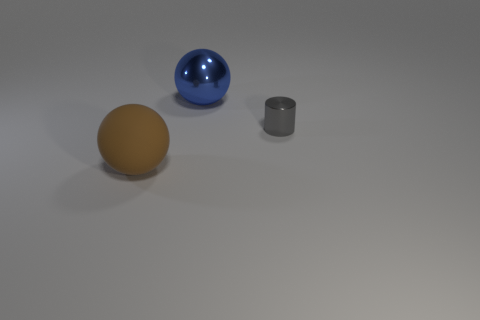Subtract all brown balls. How many balls are left? 1 Subtract 1 cylinders. How many cylinders are left? 0 Add 2 small red matte balls. How many objects exist? 5 Subtract all cylinders. How many objects are left? 2 Add 3 matte objects. How many matte objects exist? 4 Subtract 0 cyan balls. How many objects are left? 3 Subtract all green cylinders. Subtract all green cubes. How many cylinders are left? 1 Subtract all purple cylinders. How many brown balls are left? 1 Subtract all big rubber spheres. Subtract all gray objects. How many objects are left? 1 Add 1 big blue things. How many big blue things are left? 2 